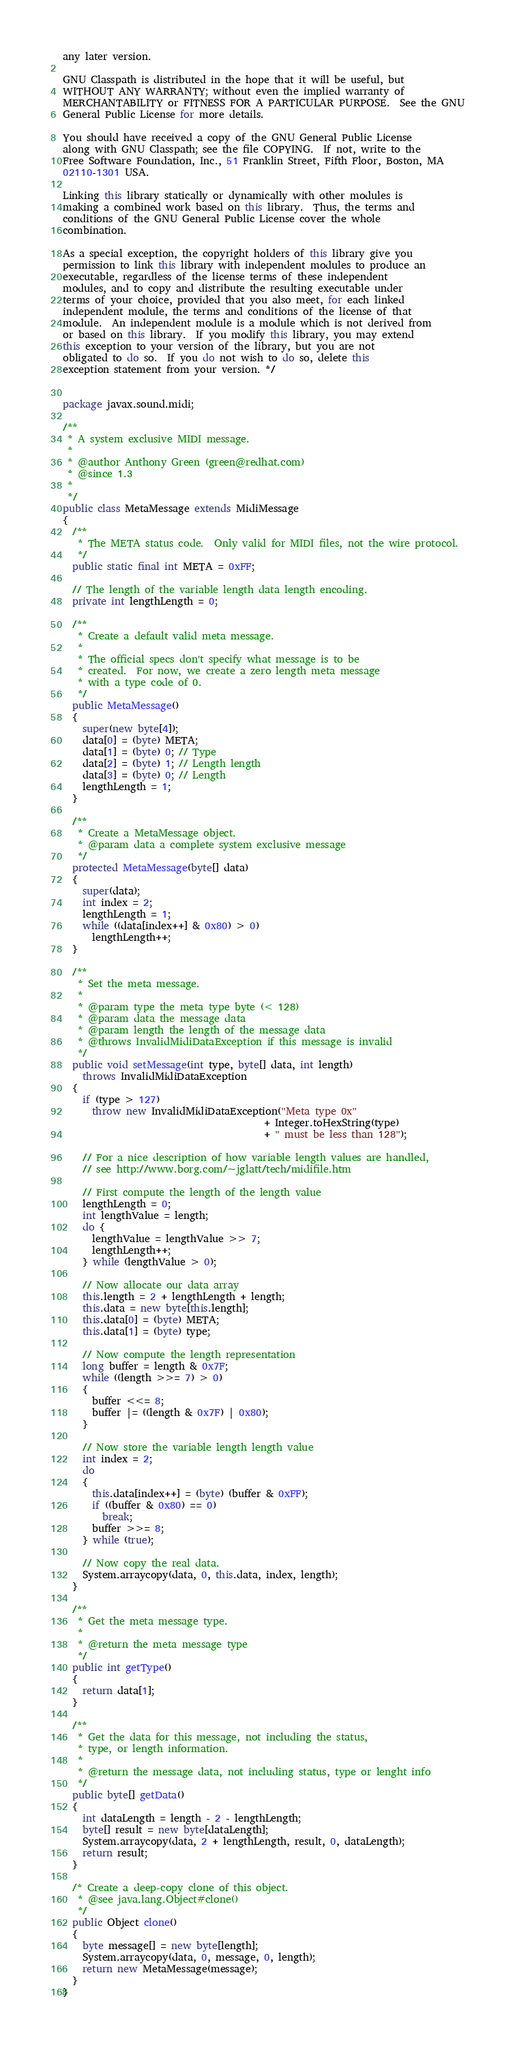<code> <loc_0><loc_0><loc_500><loc_500><_Java_>any later version.

GNU Classpath is distributed in the hope that it will be useful, but
WITHOUT ANY WARRANTY; without even the implied warranty of
MERCHANTABILITY or FITNESS FOR A PARTICULAR PURPOSE.  See the GNU
General Public License for more details.

You should have received a copy of the GNU General Public License
along with GNU Classpath; see the file COPYING.  If not, write to the
Free Software Foundation, Inc., 51 Franklin Street, Fifth Floor, Boston, MA
02110-1301 USA.

Linking this library statically or dynamically with other modules is
making a combined work based on this library.  Thus, the terms and
conditions of the GNU General Public License cover the whole
combination.

As a special exception, the copyright holders of this library give you
permission to link this library with independent modules to produce an
executable, regardless of the license terms of these independent
modules, and to copy and distribute the resulting executable under
terms of your choice, provided that you also meet, for each linked
independent module, the terms and conditions of the license of that
module.  An independent module is a module which is not derived from
or based on this library.  If you modify this library, you may extend
this exception to your version of the library, but you are not
obligated to do so.  If you do not wish to do so, delete this
exception statement from your version. */


package javax.sound.midi;

/**
 * A system exclusive MIDI message.
 * 
 * @author Anthony Green (green@redhat.com)
 * @since 1.3
 *
 */
public class MetaMessage extends MidiMessage
{
  /**
   * The META status code.  Only valid for MIDI files, not the wire protocol.
   */
  public static final int META = 0xFF;
  
  // The length of the variable length data length encoding.
  private int lengthLength = 0;
  
  /**
   * Create a default valid meta message.
   * 
   * The official specs don't specify what message is to be
   * created.  For now, we create a zero length meta message 
   * with a type code of 0.
   */
  public MetaMessage()
  {
    super(new byte[4]);
    data[0] = (byte) META;
    data[1] = (byte) 0; // Type
    data[2] = (byte) 1; // Length length
    data[3] = (byte) 0; // Length
    lengthLength = 1;
  }
  
  /**
   * Create a MetaMessage object.
   * @param data a complete system exclusive message
   */
  protected MetaMessage(byte[] data)
  {
    super(data);
    int index = 2;
    lengthLength = 1;
    while ((data[index++] & 0x80) > 0)
      lengthLength++;
  }
  
  /**
   * Set the meta message.
   *  
   * @param type the meta type byte (< 128)
   * @param data the message data
   * @param length the length of the message data
   * @throws InvalidMidiDataException if this message is invalid
   */
  public void setMessage(int type, byte[] data, int length)
    throws InvalidMidiDataException
  {
    if (type > 127)
      throw new InvalidMidiDataException("Meta type 0x"
                                         + Integer.toHexString(type)
                                         + " must be less than 128");

    // For a nice description of how variable length values are handled, 
    // see http://www.borg.com/~jglatt/tech/midifile.htm
    
    // First compute the length of the length value
    lengthLength = 0;
    int lengthValue = length;
    do {
      lengthValue = lengthValue >> 7;
      lengthLength++;
    } while (lengthValue > 0);
    
    // Now allocate our data array
    this.length = 2 + lengthLength + length;
    this.data = new byte[this.length];
    this.data[0] = (byte) META;
    this.data[1] = (byte) type;
    
    // Now compute the length representation
    long buffer = length & 0x7F;
    while ((length >>= 7) > 0)
    {
      buffer <<= 8;
      buffer |= ((length & 0x7F) | 0x80);
    }
    
    // Now store the variable length length value
    int index = 2;
    do
    {
      this.data[index++] = (byte) (buffer & 0xFF);
      if ((buffer & 0x80) == 0)
        break;
      buffer >>= 8;
    } while (true);
 
    // Now copy the real data.
    System.arraycopy(data, 0, this.data, index, length);
  }
  
  /**
   * Get the meta message type.
   * 
   * @return the meta message type
   */
  public int getType()
  {
    return data[1];
  }
  
  /**
   * Get the data for this message, not including the status,
   * type, or length information.
   * 
   * @return the message data, not including status, type or lenght info
   */
  public byte[] getData()
  {
    int dataLength = length - 2 - lengthLength;
    byte[] result = new byte[dataLength];
    System.arraycopy(data, 2 + lengthLength, result, 0, dataLength);
    return result;
  }
  
  /* Create a deep-copy clone of this object.
   * @see java.lang.Object#clone()
   */
  public Object clone()
  {
    byte message[] = new byte[length];
    System.arraycopy(data, 0, message, 0, length);
    return new MetaMessage(message); 
  }
}
</code> 